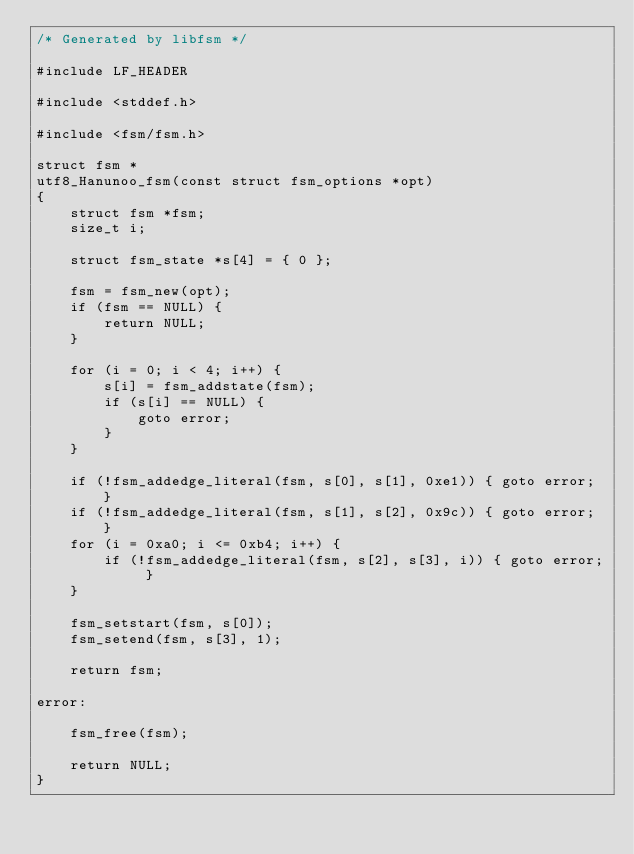Convert code to text. <code><loc_0><loc_0><loc_500><loc_500><_C_>/* Generated by libfsm */

#include LF_HEADER

#include <stddef.h>

#include <fsm/fsm.h>

struct fsm *
utf8_Hanunoo_fsm(const struct fsm_options *opt)
{
	struct fsm *fsm;
	size_t i;

	struct fsm_state *s[4] = { 0 };

	fsm = fsm_new(opt);
	if (fsm == NULL) {
		return NULL;
	}

	for (i = 0; i < 4; i++) {
		s[i] = fsm_addstate(fsm);
		if (s[i] == NULL) {
			goto error;
		}
	}

	if (!fsm_addedge_literal(fsm, s[0], s[1], 0xe1)) { goto error; }
	if (!fsm_addedge_literal(fsm, s[1], s[2], 0x9c)) { goto error; }
	for (i = 0xa0; i <= 0xb4; i++) {
		if (!fsm_addedge_literal(fsm, s[2], s[3], i)) { goto error; }
	}

	fsm_setstart(fsm, s[0]);
	fsm_setend(fsm, s[3], 1);

	return fsm;

error:

	fsm_free(fsm);

	return NULL;
}

</code> 